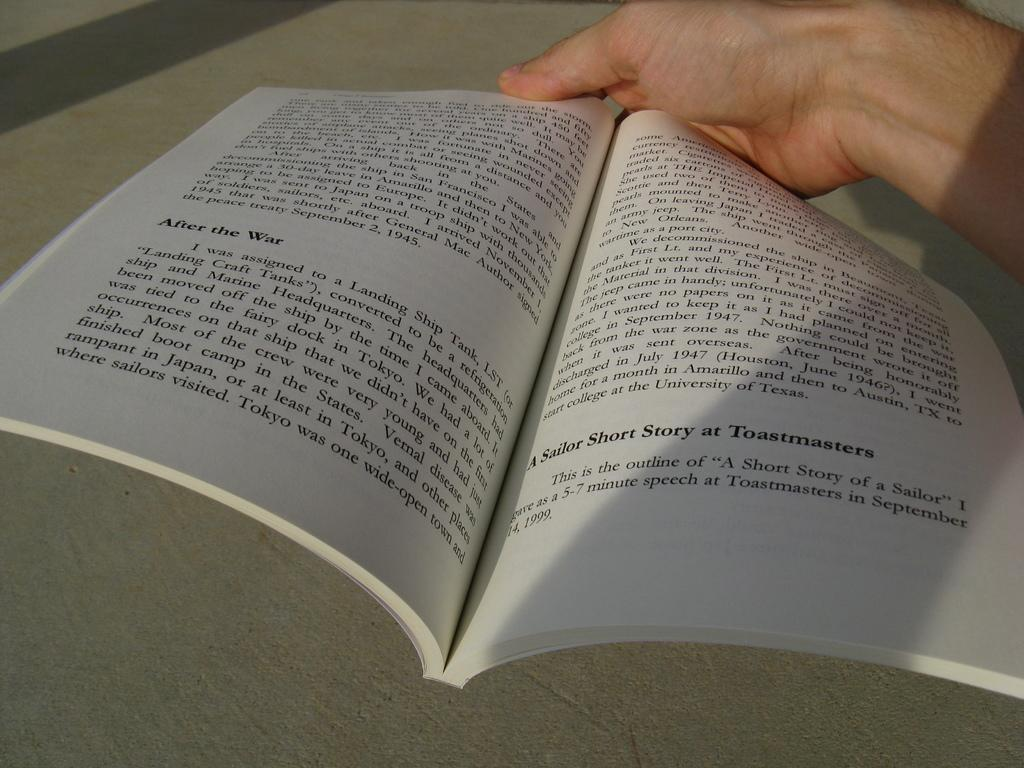Provide a one-sentence caption for the provided image. The book is full of short stories of only a few paragraphs each. 